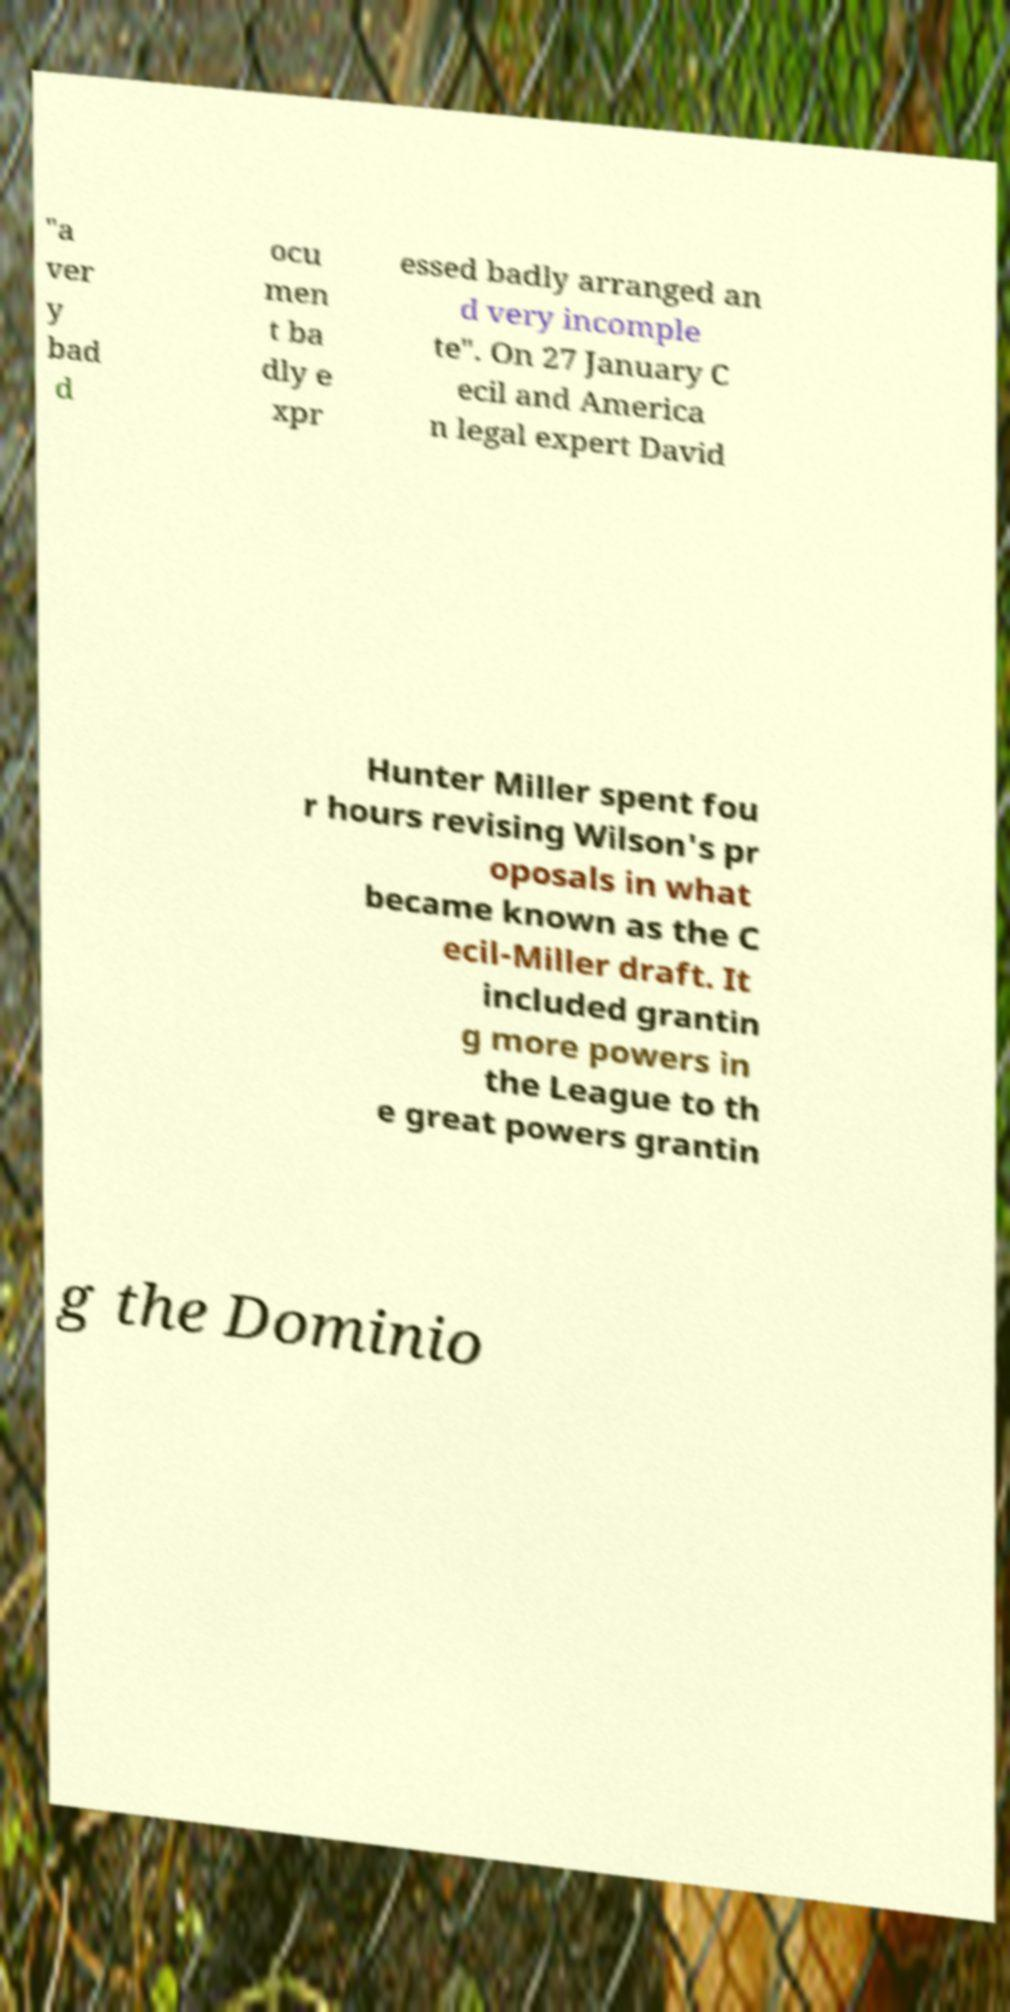Please read and relay the text visible in this image. What does it say? "a ver y bad d ocu men t ba dly e xpr essed badly arranged an d very incomple te". On 27 January C ecil and America n legal expert David Hunter Miller spent fou r hours revising Wilson's pr oposals in what became known as the C ecil-Miller draft. It included grantin g more powers in the League to th e great powers grantin g the Dominio 